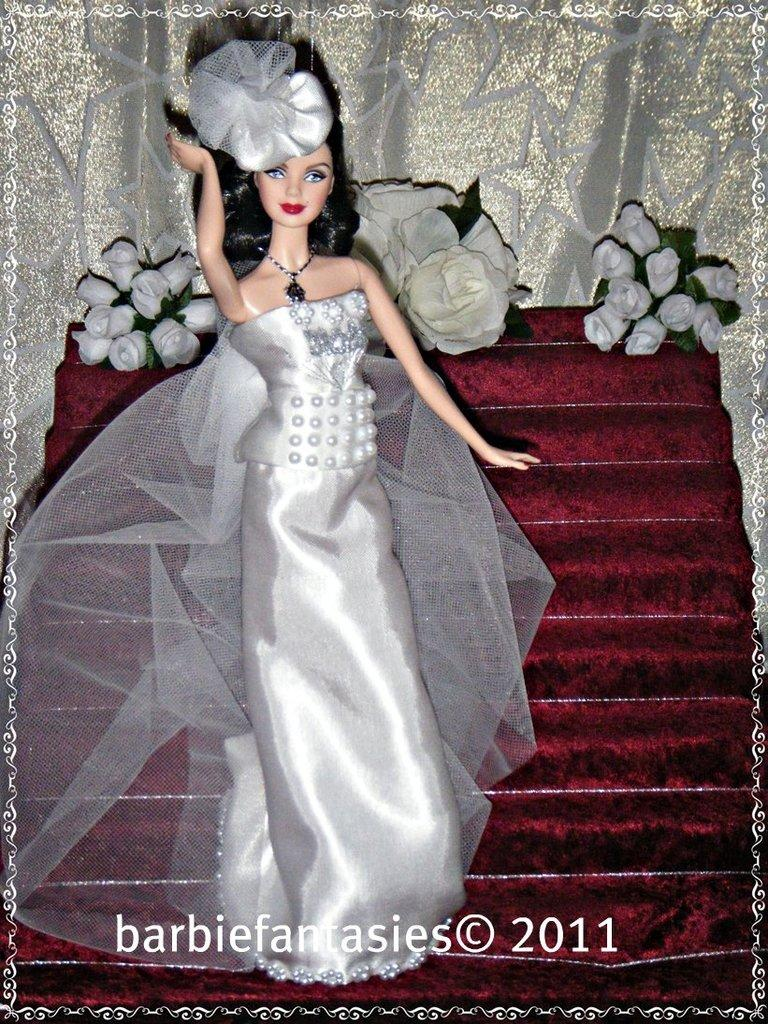What type of toy is in the image? There is a Barbie doll toy in the image. What is the Barbie doll wearing? The Barbie doll is wearing a silver dress. What is the Barbie doll standing on? The Barbie doll is standing on red carpet steps. What can be seen in the background of the image? There are white flowers visible in the background of the image. What type of breakfast is being served on the plane in the image? There is no plane or breakfast present in the image; it features a Barbie doll toy standing on red carpet steps with white flowers in the background. 